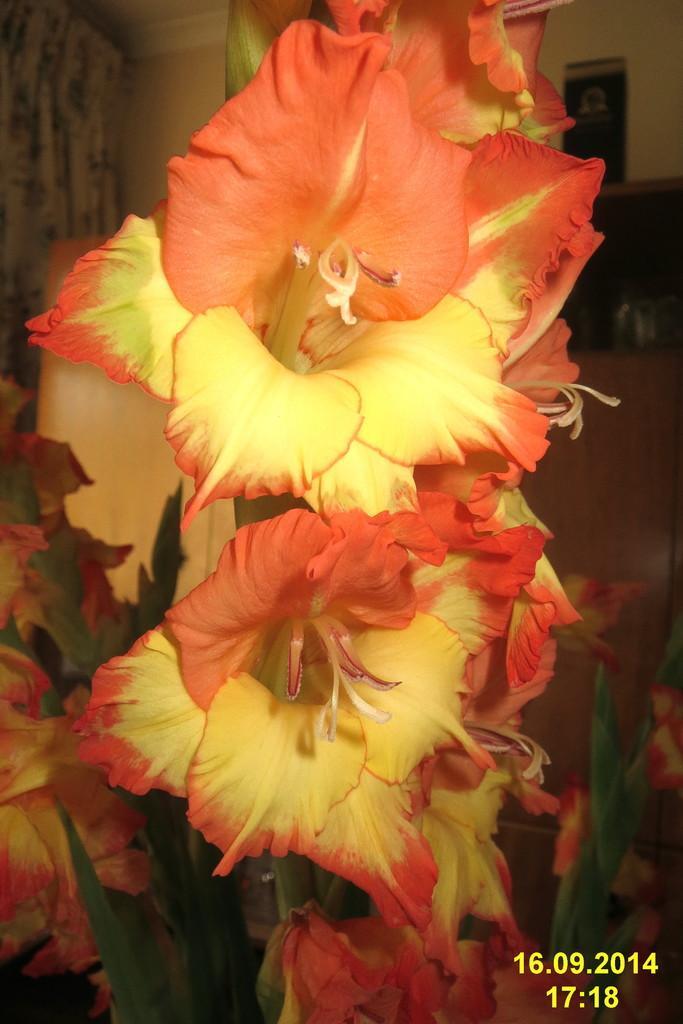In one or two sentences, can you explain what this image depicts? In the center of the image there are flowers. To the right side bottom of the image there is text. 